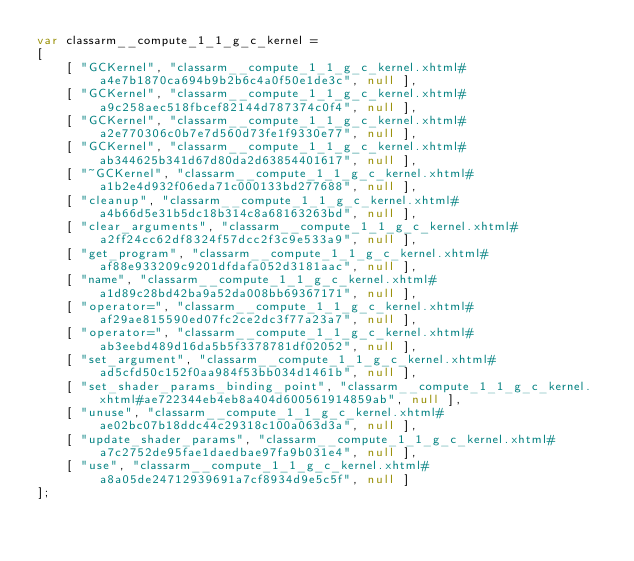Convert code to text. <code><loc_0><loc_0><loc_500><loc_500><_JavaScript_>var classarm__compute_1_1_g_c_kernel =
[
    [ "GCKernel", "classarm__compute_1_1_g_c_kernel.xhtml#a4e7b1870ca694b9b2b6c4a0f50e1de3c", null ],
    [ "GCKernel", "classarm__compute_1_1_g_c_kernel.xhtml#a9c258aec518fbcef82144d787374c0f4", null ],
    [ "GCKernel", "classarm__compute_1_1_g_c_kernel.xhtml#a2e770306c0b7e7d560d73fe1f9330e77", null ],
    [ "GCKernel", "classarm__compute_1_1_g_c_kernel.xhtml#ab344625b341d67d80da2d63854401617", null ],
    [ "~GCKernel", "classarm__compute_1_1_g_c_kernel.xhtml#a1b2e4d932f06eda71c000133bd277688", null ],
    [ "cleanup", "classarm__compute_1_1_g_c_kernel.xhtml#a4b66d5e31b5dc18b314c8a68163263bd", null ],
    [ "clear_arguments", "classarm__compute_1_1_g_c_kernel.xhtml#a2ff24cc62df8324f57dcc2f3c9e533a9", null ],
    [ "get_program", "classarm__compute_1_1_g_c_kernel.xhtml#af88e933209c9201dfdafa052d3181aac", null ],
    [ "name", "classarm__compute_1_1_g_c_kernel.xhtml#a1d89c28bd42ba9a52da008bb69367171", null ],
    [ "operator=", "classarm__compute_1_1_g_c_kernel.xhtml#af29ae815590ed07fc2ce2dc3f77a23a7", null ],
    [ "operator=", "classarm__compute_1_1_g_c_kernel.xhtml#ab3eebd489d16da5b5f3378781df02052", null ],
    [ "set_argument", "classarm__compute_1_1_g_c_kernel.xhtml#ad5cfd50c152f0aa984f53bb034d1461b", null ],
    [ "set_shader_params_binding_point", "classarm__compute_1_1_g_c_kernel.xhtml#ae722344eb4eb8a404d600561914859ab", null ],
    [ "unuse", "classarm__compute_1_1_g_c_kernel.xhtml#ae02bc07b18ddc44c29318c100a063d3a", null ],
    [ "update_shader_params", "classarm__compute_1_1_g_c_kernel.xhtml#a7c2752de95fae1daedbae97fa9b031e4", null ],
    [ "use", "classarm__compute_1_1_g_c_kernel.xhtml#a8a05de24712939691a7cf8934d9e5c5f", null ]
];</code> 